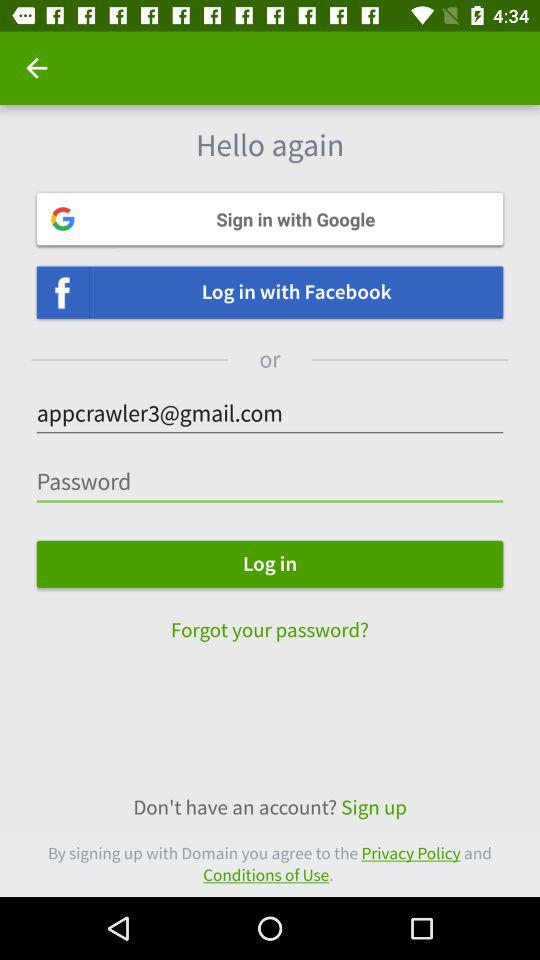How many sign-in options are there?
Answer the question using a single word or phrase. 2 